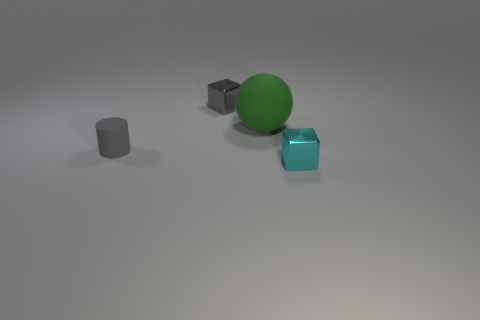What is the color of the other object that is the same shape as the cyan thing?
Your response must be concise. Gray. There is a rubber cylinder; does it have the same color as the small thing that is right of the green thing?
Ensure brevity in your answer.  No. What is the shape of the object that is both right of the gray cube and behind the gray cylinder?
Provide a short and direct response. Sphere. Are there fewer tiny metallic objects than brown shiny blocks?
Offer a terse response. No. Are any big matte things visible?
Make the answer very short. Yes. What number of other things are there of the same size as the gray block?
Make the answer very short. 2. Is the green sphere made of the same material as the tiny cube that is left of the cyan object?
Provide a short and direct response. No. Are there the same number of small gray matte cylinders right of the small cyan cube and small gray shiny cubes that are in front of the tiny gray cylinder?
Provide a succinct answer. Yes. What is the large sphere made of?
Your answer should be compact. Rubber. There is another cube that is the same size as the gray shiny cube; what color is it?
Your answer should be very brief. Cyan. 